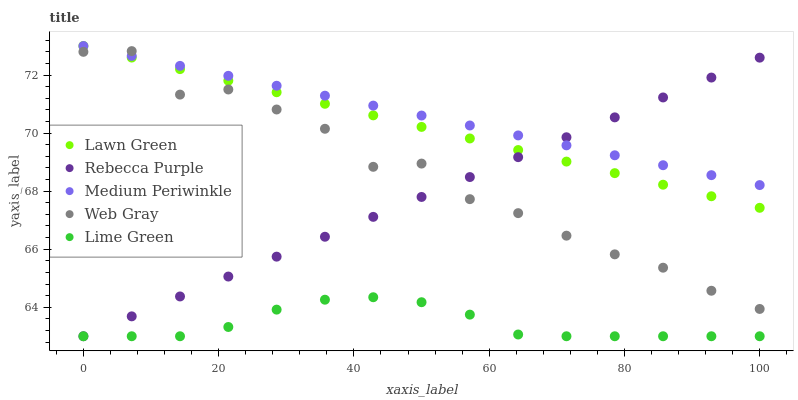Does Lime Green have the minimum area under the curve?
Answer yes or no. Yes. Does Medium Periwinkle have the maximum area under the curve?
Answer yes or no. Yes. Does Web Gray have the minimum area under the curve?
Answer yes or no. No. Does Web Gray have the maximum area under the curve?
Answer yes or no. No. Is Medium Periwinkle the smoothest?
Answer yes or no. Yes. Is Web Gray the roughest?
Answer yes or no. Yes. Is Web Gray the smoothest?
Answer yes or no. No. Is Medium Periwinkle the roughest?
Answer yes or no. No. Does Rebecca Purple have the lowest value?
Answer yes or no. Yes. Does Web Gray have the lowest value?
Answer yes or no. No. Does Medium Periwinkle have the highest value?
Answer yes or no. Yes. Does Web Gray have the highest value?
Answer yes or no. No. Is Lime Green less than Lawn Green?
Answer yes or no. Yes. Is Web Gray greater than Lime Green?
Answer yes or no. Yes. Does Web Gray intersect Lawn Green?
Answer yes or no. Yes. Is Web Gray less than Lawn Green?
Answer yes or no. No. Is Web Gray greater than Lawn Green?
Answer yes or no. No. Does Lime Green intersect Lawn Green?
Answer yes or no. No. 